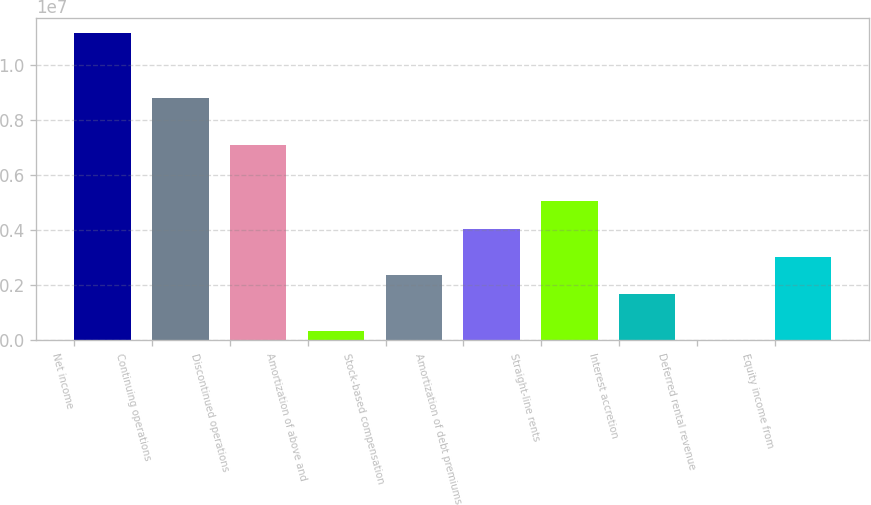Convert chart. <chart><loc_0><loc_0><loc_500><loc_500><bar_chart><fcel>Net income<fcel>Continuing operations<fcel>Discontinued operations<fcel>Amortization of above and<fcel>Stock-based compensation<fcel>Amortization of debt premiums<fcel>Straight-line rents<fcel>Interest accretion<fcel>Deferred rental revenue<fcel>Equity income from<nl><fcel>1.11789e+07<fcel>8.80776e+06<fcel>7.11406e+06<fcel>339258<fcel>2.3717e+06<fcel>4.0654e+06<fcel>5.08162e+06<fcel>1.69422e+06<fcel>518<fcel>3.04918e+06<nl></chart> 